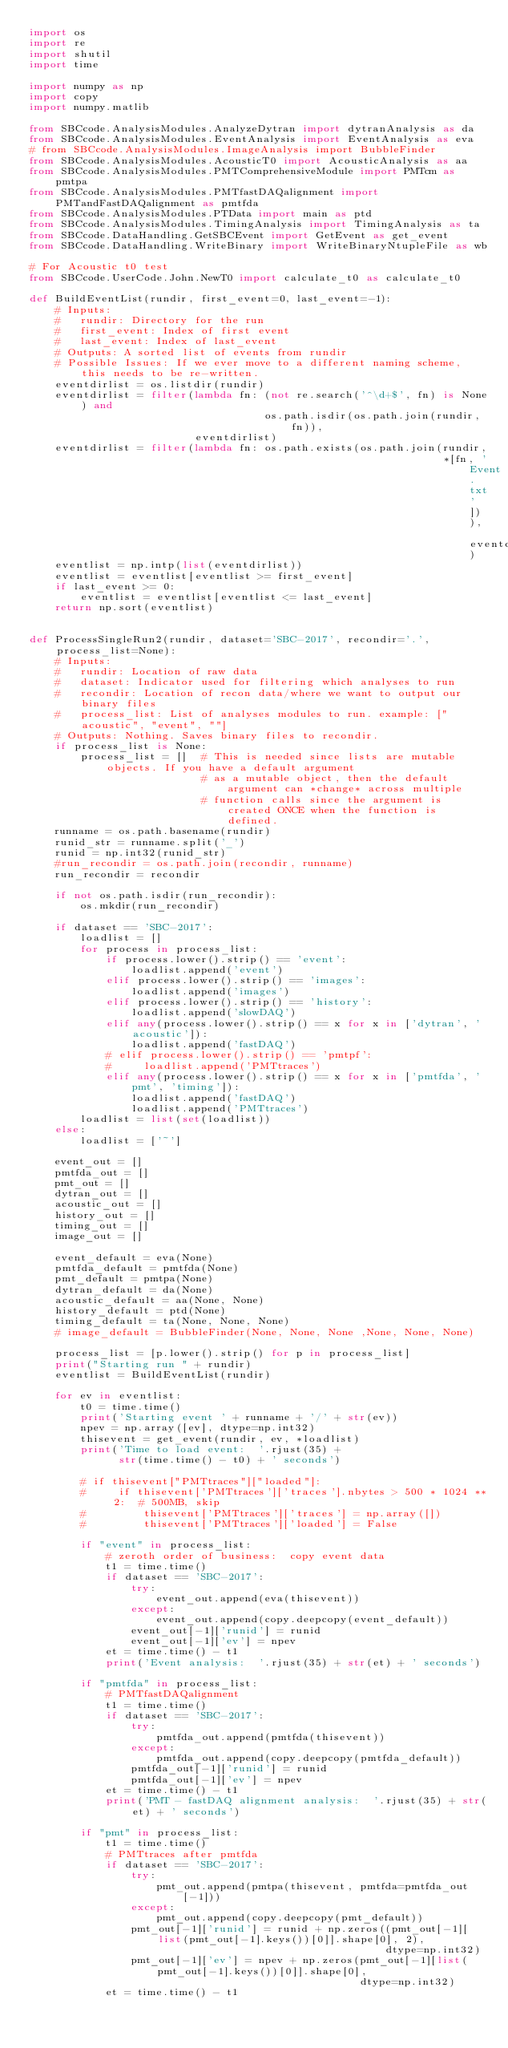Convert code to text. <code><loc_0><loc_0><loc_500><loc_500><_Python_>import os
import re
import shutil
import time

import numpy as np
import copy
import numpy.matlib

from SBCcode.AnalysisModules.AnalyzeDytran import dytranAnalysis as da
from SBCcode.AnalysisModules.EventAnalysis import EventAnalysis as eva
# from SBCcode.AnalysisModules.ImageAnalysis import BubbleFinder
from SBCcode.AnalysisModules.AcousticT0 import AcousticAnalysis as aa
from SBCcode.AnalysisModules.PMTComprehensiveModule import PMTcm as pmtpa
from SBCcode.AnalysisModules.PMTfastDAQalignment import PMTandFastDAQalignment as pmtfda
from SBCcode.AnalysisModules.PTData import main as ptd
from SBCcode.AnalysisModules.TimingAnalysis import TimingAnalysis as ta
from SBCcode.DataHandling.GetSBCEvent import GetEvent as get_event
from SBCcode.DataHandling.WriteBinary import WriteBinaryNtupleFile as wb

# For Acoustic t0 test
from SBCcode.UserCode.John.NewT0 import calculate_t0 as calculate_t0

def BuildEventList(rundir, first_event=0, last_event=-1):
    # Inputs:
    #   rundir: Directory for the run
    #   first_event: Index of first event
    #   last_event: Index of last_event
    # Outputs: A sorted list of events from rundir
    # Possible Issues: If we ever move to a different naming scheme, this needs to be re-written.
    eventdirlist = os.listdir(rundir)
    eventdirlist = filter(lambda fn: (not re.search('^\d+$', fn) is None) and
                                     os.path.isdir(os.path.join(rundir, fn)),
                          eventdirlist)
    eventdirlist = filter(lambda fn: os.path.exists(os.path.join(rundir,
                                                                 *[fn, 'Event.txt'])), eventdirlist)
    eventlist = np.intp(list(eventdirlist))
    eventlist = eventlist[eventlist >= first_event]
    if last_event >= 0:
        eventlist = eventlist[eventlist <= last_event]
    return np.sort(eventlist)


def ProcessSingleRun2(rundir, dataset='SBC-2017', recondir='.', process_list=None):
    # Inputs:
    #   rundir: Location of raw data
    #   dataset: Indicator used for filtering which analyses to run
    #   recondir: Location of recon data/where we want to output our binary files
    #   process_list: List of analyses modules to run. example: ["acoustic", "event", ""]
    # Outputs: Nothing. Saves binary files to recondir.
    if process_list is None:
        process_list = []  # This is needed since lists are mutable objects. If you have a default argument
                           # as a mutable object, then the default argument can *change* across multiple
                           # function calls since the argument is created ONCE when the function is defined.
    runname = os.path.basename(rundir)
    runid_str = runname.split('_')
    runid = np.int32(runid_str)
    #run_recondir = os.path.join(recondir, runname)
    run_recondir = recondir

    if not os.path.isdir(run_recondir):
        os.mkdir(run_recondir)

    if dataset == 'SBC-2017':
        loadlist = []
        for process in process_list:
            if process.lower().strip() == 'event':
                loadlist.append('event')
            elif process.lower().strip() == 'images':
                loadlist.append('images')
            elif process.lower().strip() == 'history':
                loadlist.append('slowDAQ')
            elif any(process.lower().strip() == x for x in ['dytran', 'acoustic']):
                loadlist.append('fastDAQ')
            # elif process.lower().strip() == 'pmtpf':
            #     loadlist.append('PMTtraces')
            elif any(process.lower().strip() == x for x in ['pmtfda', 'pmt', 'timing']):
                loadlist.append('fastDAQ')
                loadlist.append('PMTtraces')
        loadlist = list(set(loadlist))
    else:
        loadlist = ['~']

    event_out = []
    pmtfda_out = []
    pmt_out = []
    dytran_out = []
    acoustic_out = []
    history_out = []
    timing_out = []
    image_out = []

    event_default = eva(None)
    pmtfda_default = pmtfda(None)
    pmt_default = pmtpa(None)
    dytran_default = da(None)
    acoustic_default = aa(None, None)
    history_default = ptd(None)
    timing_default = ta(None, None, None)
    # image_default = BubbleFinder(None, None, None ,None, None, None)

    process_list = [p.lower().strip() for p in process_list]
    print("Starting run " + rundir)
    eventlist = BuildEventList(rundir)

    for ev in eventlist:
        t0 = time.time()
        print('Starting event ' + runname + '/' + str(ev))
        npev = np.array([ev], dtype=np.int32)
        thisevent = get_event(rundir, ev, *loadlist)
        print('Time to load event:  '.rjust(35) +
              str(time.time() - t0) + ' seconds')

        # if thisevent["PMTtraces"]["loaded"]:
        #     if thisevent['PMTtraces']['traces'].nbytes > 500 * 1024 ** 2:  # 500MB, skip
        #         thisevent['PMTtraces']['traces'] = np.array([])
        #         thisevent['PMTtraces']['loaded'] = False

        if "event" in process_list:
            # zeroth order of business:  copy event data
            t1 = time.time()
            if dataset == 'SBC-2017':
                try:
                    event_out.append(eva(thisevent))
                except:
                    event_out.append(copy.deepcopy(event_default))
                event_out[-1]['runid'] = runid
                event_out[-1]['ev'] = npev
            et = time.time() - t1
            print('Event analysis:  '.rjust(35) + str(et) + ' seconds')

        if "pmtfda" in process_list:
            # PMTfastDAQalignment
            t1 = time.time()
            if dataset == 'SBC-2017':
                try:
                    pmtfda_out.append(pmtfda(thisevent))
                except:
                    pmtfda_out.append(copy.deepcopy(pmtfda_default))
                pmtfda_out[-1]['runid'] = runid
                pmtfda_out[-1]['ev'] = npev
            et = time.time() - t1
            print('PMT - fastDAQ alignment analysis:  '.rjust(35) + str(et) + ' seconds')

        if "pmt" in process_list:
            t1 = time.time()
            # PMTtraces after pmtfda
            if dataset == 'SBC-2017':
                try:
                    pmt_out.append(pmtpa(thisevent, pmtfda=pmtfda_out[-1]))
                except:
                    pmt_out.append(copy.deepcopy(pmt_default))
                pmt_out[-1]['runid'] = runid + np.zeros((pmt_out[-1][list(pmt_out[-1].keys())[0]].shape[0], 2),
                                                        dtype=np.int32)
                pmt_out[-1]['ev'] = npev + np.zeros(pmt_out[-1][list(pmt_out[-1].keys())[0]].shape[0],
                                                    dtype=np.int32)
            et = time.time() - t1</code> 